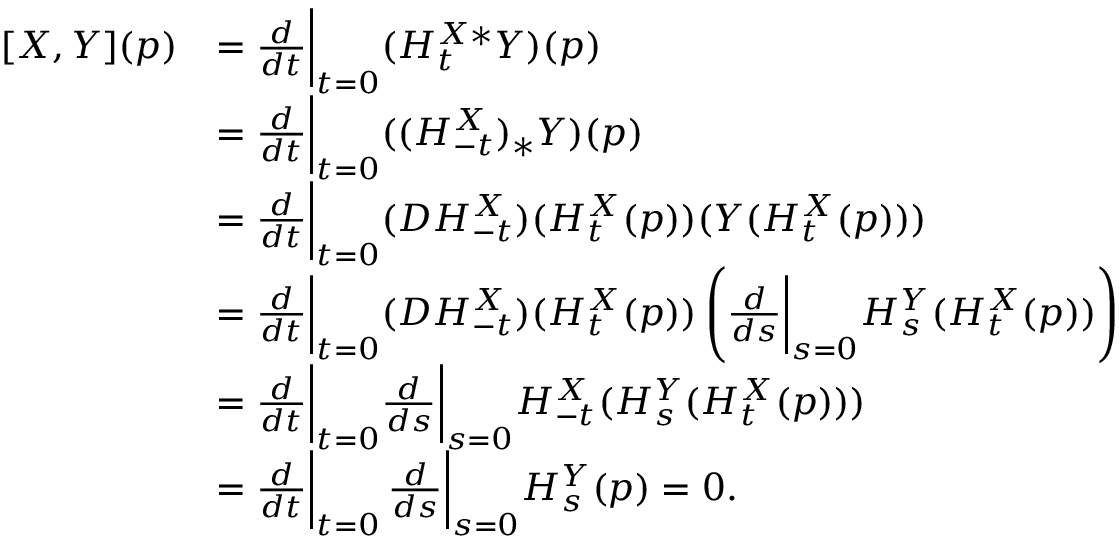Convert formula to latex. <formula><loc_0><loc_0><loc_500><loc_500>\begin{array} { r l } { [ X , Y ] ( p ) } & { = \frac { d } { d t } \Big | _ { t = 0 } ( H _ { t } ^ { X * } Y ) ( p ) } \\ & { = \frac { d } { d t } \Big | _ { t = 0 } ( ( H _ { - t } ^ { X } ) _ { * } Y ) ( p ) } \\ & { = \frac { d } { d t } \Big | _ { t = 0 } ( D H _ { - t } ^ { X } ) ( H _ { t } ^ { X } ( p ) ) ( Y ( H _ { t } ^ { X } ( p ) ) ) } \\ & { = \frac { d } { d t } \Big | _ { t = 0 } ( D H _ { - t } ^ { X } ) ( H _ { t } ^ { X } ( p ) ) \left ( \frac { d } { d s } \Big | _ { s = 0 } H _ { s } ^ { Y } ( H _ { t } ^ { X } ( p ) ) \right ) } \\ & { = \frac { d } { d t } \Big | _ { t = 0 } \frac { d } { d s } \Big | _ { s = 0 } H _ { - t } ^ { X } ( H _ { s } ^ { Y } ( H _ { t } ^ { X } ( p ) ) ) } \\ & { = \frac { d } { d t } \Big | _ { t = 0 } \, \frac { d } { d s } \Big | _ { s = 0 } H _ { s } ^ { Y } ( p ) = 0 . } \end{array}</formula> 